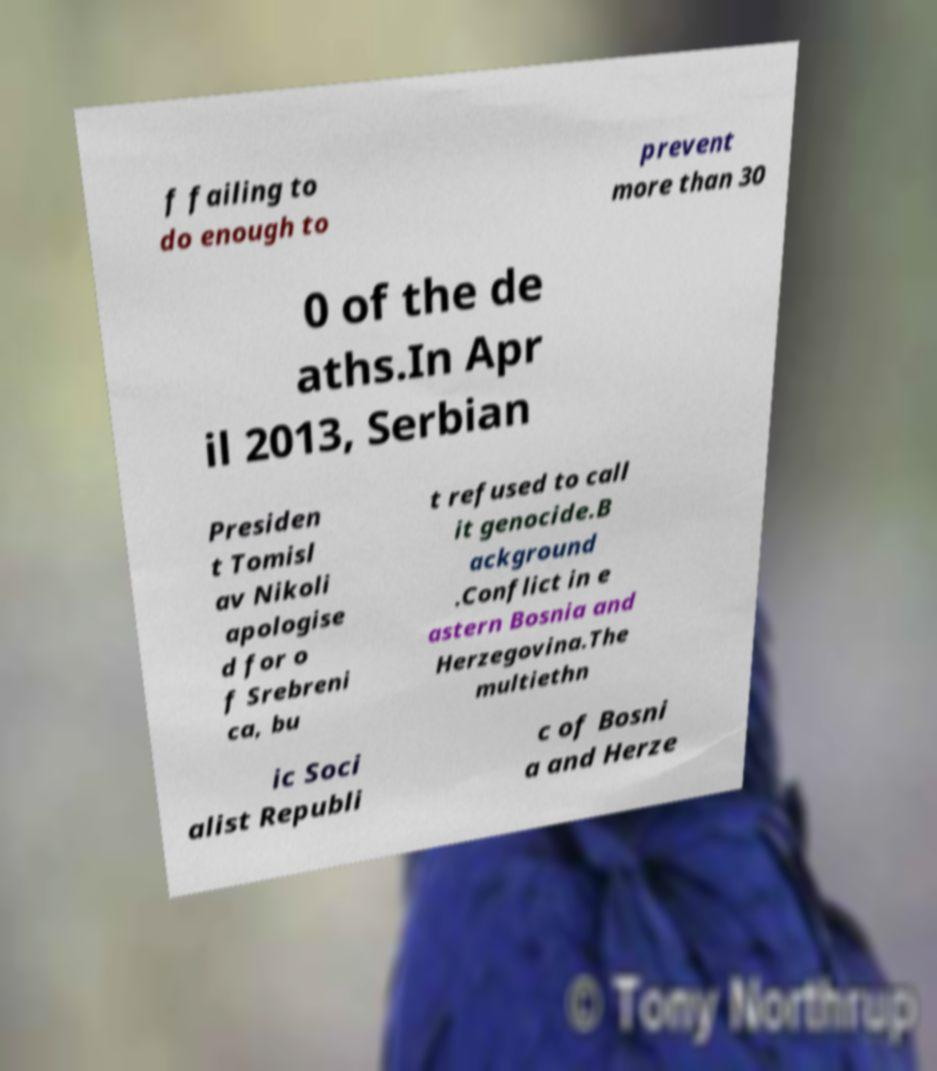Please read and relay the text visible in this image. What does it say? f failing to do enough to prevent more than 30 0 of the de aths.In Apr il 2013, Serbian Presiden t Tomisl av Nikoli apologise d for o f Srebreni ca, bu t refused to call it genocide.B ackground .Conflict in e astern Bosnia and Herzegovina.The multiethn ic Soci alist Republi c of Bosni a and Herze 